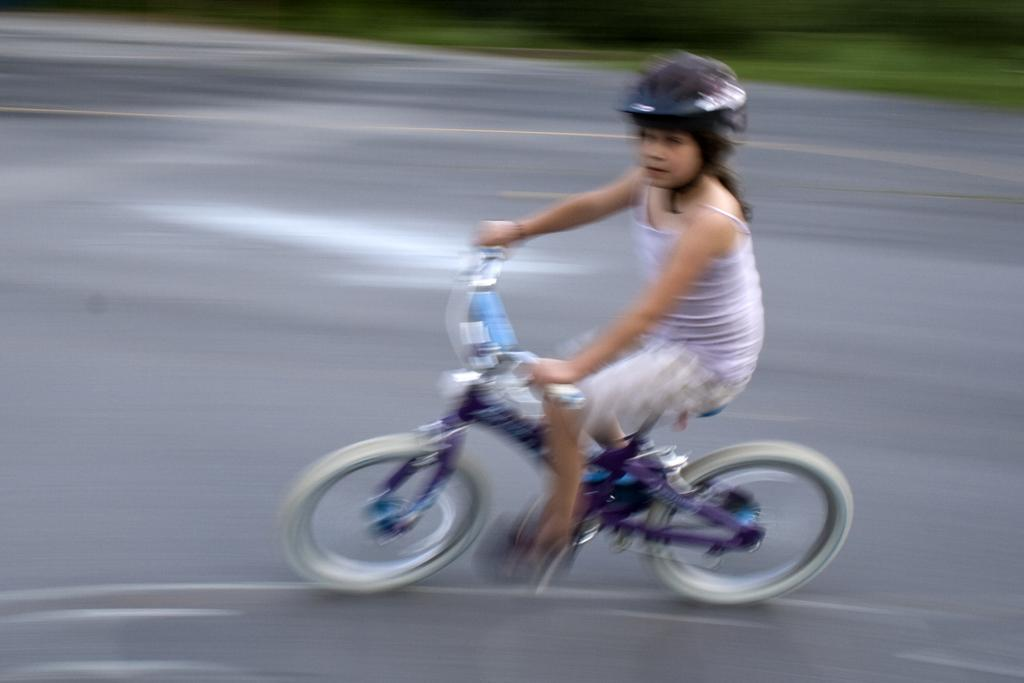Who is the main subject in the image? There is a girl in the image. What is the girl doing in the image? The girl is on a cycle. Where is the girl located in the image? The girl is on a path. What type of building can be seen in the background of the image? There is no building visible in the background of the image; it only features the girl on a cycle on a path. What type of fabric is the girl wearing in the image? The provided facts do not mention the type of fabric the girl is wearing, so it cannot be determined from the image. 